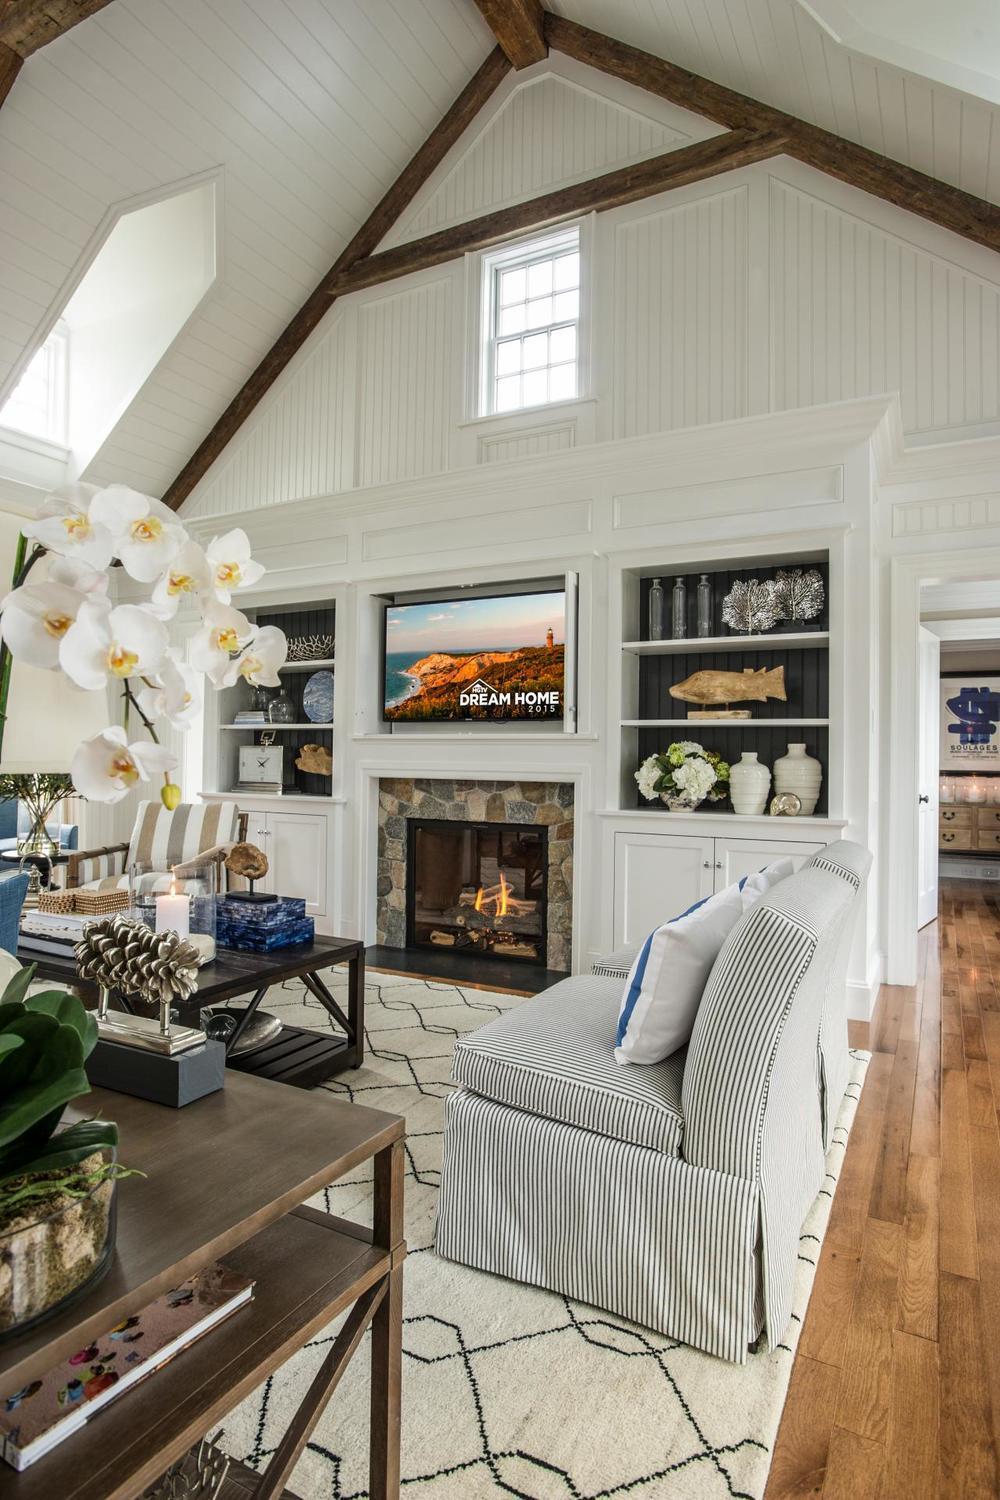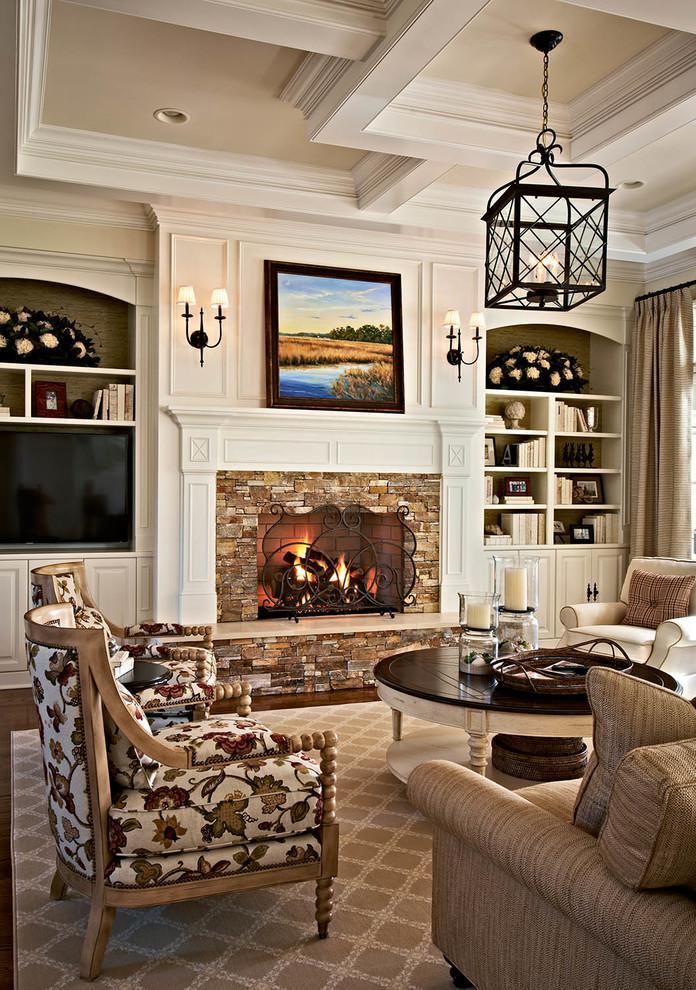The first image is the image on the left, the second image is the image on the right. Given the left and right images, does the statement "One image shows a room with peaked, beamed ceiling above bookshelves and other furniture." hold true? Answer yes or no. Yes. 